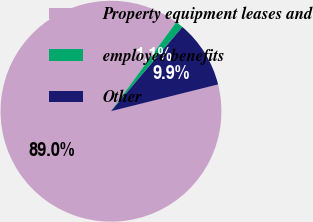Convert chart to OTSL. <chart><loc_0><loc_0><loc_500><loc_500><pie_chart><fcel>Property equipment leases and<fcel>employee benefits<fcel>Other<nl><fcel>88.96%<fcel>1.13%<fcel>9.91%<nl></chart> 